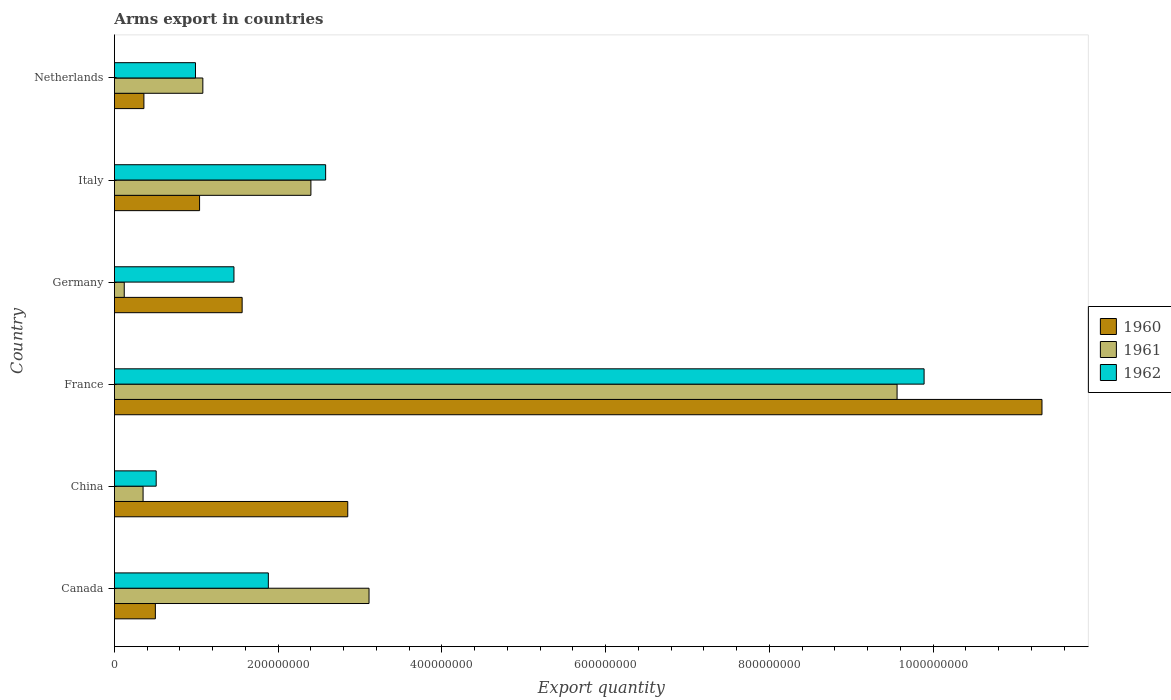How many groups of bars are there?
Offer a terse response. 6. How many bars are there on the 6th tick from the top?
Provide a short and direct response. 3. What is the label of the 2nd group of bars from the top?
Keep it short and to the point. Italy. In how many cases, is the number of bars for a given country not equal to the number of legend labels?
Offer a terse response. 0. What is the total arms export in 1960 in Netherlands?
Your answer should be compact. 3.60e+07. Across all countries, what is the maximum total arms export in 1961?
Offer a very short reply. 9.56e+08. Across all countries, what is the minimum total arms export in 1962?
Provide a succinct answer. 5.10e+07. What is the total total arms export in 1962 in the graph?
Offer a very short reply. 1.73e+09. What is the difference between the total arms export in 1960 in Canada and that in Germany?
Provide a succinct answer. -1.06e+08. What is the difference between the total arms export in 1961 in China and the total arms export in 1960 in France?
Your answer should be compact. -1.10e+09. What is the average total arms export in 1960 per country?
Offer a terse response. 2.94e+08. What is the difference between the total arms export in 1961 and total arms export in 1962 in China?
Offer a very short reply. -1.60e+07. What is the ratio of the total arms export in 1961 in China to that in Netherlands?
Keep it short and to the point. 0.32. Is the difference between the total arms export in 1961 in Italy and Netherlands greater than the difference between the total arms export in 1962 in Italy and Netherlands?
Ensure brevity in your answer.  No. What is the difference between the highest and the second highest total arms export in 1962?
Make the answer very short. 7.31e+08. What is the difference between the highest and the lowest total arms export in 1961?
Keep it short and to the point. 9.44e+08. In how many countries, is the total arms export in 1961 greater than the average total arms export in 1961 taken over all countries?
Ensure brevity in your answer.  2. What does the 2nd bar from the top in Canada represents?
Your answer should be compact. 1961. What does the 1st bar from the bottom in Italy represents?
Your response must be concise. 1960. How many bars are there?
Offer a very short reply. 18. What is the difference between two consecutive major ticks on the X-axis?
Give a very brief answer. 2.00e+08. Are the values on the major ticks of X-axis written in scientific E-notation?
Your answer should be compact. No. Does the graph contain any zero values?
Offer a terse response. No. Does the graph contain grids?
Offer a terse response. No. Where does the legend appear in the graph?
Keep it short and to the point. Center right. How many legend labels are there?
Offer a terse response. 3. What is the title of the graph?
Ensure brevity in your answer.  Arms export in countries. Does "1972" appear as one of the legend labels in the graph?
Provide a succinct answer. No. What is the label or title of the X-axis?
Your answer should be very brief. Export quantity. What is the Export quantity in 1960 in Canada?
Provide a succinct answer. 5.00e+07. What is the Export quantity in 1961 in Canada?
Make the answer very short. 3.11e+08. What is the Export quantity in 1962 in Canada?
Your response must be concise. 1.88e+08. What is the Export quantity of 1960 in China?
Give a very brief answer. 2.85e+08. What is the Export quantity of 1961 in China?
Provide a succinct answer. 3.50e+07. What is the Export quantity in 1962 in China?
Provide a short and direct response. 5.10e+07. What is the Export quantity of 1960 in France?
Give a very brief answer. 1.13e+09. What is the Export quantity in 1961 in France?
Offer a very short reply. 9.56e+08. What is the Export quantity of 1962 in France?
Keep it short and to the point. 9.89e+08. What is the Export quantity in 1960 in Germany?
Make the answer very short. 1.56e+08. What is the Export quantity of 1961 in Germany?
Your answer should be compact. 1.20e+07. What is the Export quantity in 1962 in Germany?
Make the answer very short. 1.46e+08. What is the Export quantity in 1960 in Italy?
Provide a succinct answer. 1.04e+08. What is the Export quantity in 1961 in Italy?
Ensure brevity in your answer.  2.40e+08. What is the Export quantity in 1962 in Italy?
Offer a very short reply. 2.58e+08. What is the Export quantity of 1960 in Netherlands?
Your answer should be compact. 3.60e+07. What is the Export quantity of 1961 in Netherlands?
Offer a very short reply. 1.08e+08. What is the Export quantity of 1962 in Netherlands?
Provide a short and direct response. 9.90e+07. Across all countries, what is the maximum Export quantity of 1960?
Offer a very short reply. 1.13e+09. Across all countries, what is the maximum Export quantity in 1961?
Your answer should be compact. 9.56e+08. Across all countries, what is the maximum Export quantity in 1962?
Provide a succinct answer. 9.89e+08. Across all countries, what is the minimum Export quantity of 1960?
Your answer should be compact. 3.60e+07. Across all countries, what is the minimum Export quantity in 1962?
Provide a short and direct response. 5.10e+07. What is the total Export quantity in 1960 in the graph?
Make the answer very short. 1.76e+09. What is the total Export quantity in 1961 in the graph?
Your answer should be very brief. 1.66e+09. What is the total Export quantity in 1962 in the graph?
Give a very brief answer. 1.73e+09. What is the difference between the Export quantity in 1960 in Canada and that in China?
Your answer should be compact. -2.35e+08. What is the difference between the Export quantity in 1961 in Canada and that in China?
Ensure brevity in your answer.  2.76e+08. What is the difference between the Export quantity in 1962 in Canada and that in China?
Provide a succinct answer. 1.37e+08. What is the difference between the Export quantity in 1960 in Canada and that in France?
Offer a terse response. -1.08e+09. What is the difference between the Export quantity of 1961 in Canada and that in France?
Your answer should be compact. -6.45e+08. What is the difference between the Export quantity of 1962 in Canada and that in France?
Make the answer very short. -8.01e+08. What is the difference between the Export quantity of 1960 in Canada and that in Germany?
Your response must be concise. -1.06e+08. What is the difference between the Export quantity in 1961 in Canada and that in Germany?
Offer a terse response. 2.99e+08. What is the difference between the Export quantity of 1962 in Canada and that in Germany?
Offer a very short reply. 4.20e+07. What is the difference between the Export quantity of 1960 in Canada and that in Italy?
Offer a terse response. -5.40e+07. What is the difference between the Export quantity of 1961 in Canada and that in Italy?
Your response must be concise. 7.10e+07. What is the difference between the Export quantity in 1962 in Canada and that in Italy?
Your response must be concise. -7.00e+07. What is the difference between the Export quantity in 1960 in Canada and that in Netherlands?
Offer a terse response. 1.40e+07. What is the difference between the Export quantity in 1961 in Canada and that in Netherlands?
Your answer should be compact. 2.03e+08. What is the difference between the Export quantity of 1962 in Canada and that in Netherlands?
Give a very brief answer. 8.90e+07. What is the difference between the Export quantity in 1960 in China and that in France?
Offer a very short reply. -8.48e+08. What is the difference between the Export quantity of 1961 in China and that in France?
Offer a terse response. -9.21e+08. What is the difference between the Export quantity of 1962 in China and that in France?
Provide a succinct answer. -9.38e+08. What is the difference between the Export quantity of 1960 in China and that in Germany?
Your response must be concise. 1.29e+08. What is the difference between the Export quantity in 1961 in China and that in Germany?
Your response must be concise. 2.30e+07. What is the difference between the Export quantity of 1962 in China and that in Germany?
Your answer should be compact. -9.50e+07. What is the difference between the Export quantity of 1960 in China and that in Italy?
Provide a succinct answer. 1.81e+08. What is the difference between the Export quantity of 1961 in China and that in Italy?
Offer a very short reply. -2.05e+08. What is the difference between the Export quantity of 1962 in China and that in Italy?
Make the answer very short. -2.07e+08. What is the difference between the Export quantity in 1960 in China and that in Netherlands?
Make the answer very short. 2.49e+08. What is the difference between the Export quantity in 1961 in China and that in Netherlands?
Offer a terse response. -7.30e+07. What is the difference between the Export quantity in 1962 in China and that in Netherlands?
Ensure brevity in your answer.  -4.80e+07. What is the difference between the Export quantity in 1960 in France and that in Germany?
Keep it short and to the point. 9.77e+08. What is the difference between the Export quantity of 1961 in France and that in Germany?
Provide a short and direct response. 9.44e+08. What is the difference between the Export quantity in 1962 in France and that in Germany?
Ensure brevity in your answer.  8.43e+08. What is the difference between the Export quantity of 1960 in France and that in Italy?
Make the answer very short. 1.03e+09. What is the difference between the Export quantity in 1961 in France and that in Italy?
Give a very brief answer. 7.16e+08. What is the difference between the Export quantity of 1962 in France and that in Italy?
Give a very brief answer. 7.31e+08. What is the difference between the Export quantity in 1960 in France and that in Netherlands?
Offer a terse response. 1.10e+09. What is the difference between the Export quantity of 1961 in France and that in Netherlands?
Keep it short and to the point. 8.48e+08. What is the difference between the Export quantity of 1962 in France and that in Netherlands?
Your answer should be compact. 8.90e+08. What is the difference between the Export quantity in 1960 in Germany and that in Italy?
Provide a short and direct response. 5.20e+07. What is the difference between the Export quantity of 1961 in Germany and that in Italy?
Keep it short and to the point. -2.28e+08. What is the difference between the Export quantity in 1962 in Germany and that in Italy?
Provide a short and direct response. -1.12e+08. What is the difference between the Export quantity in 1960 in Germany and that in Netherlands?
Offer a very short reply. 1.20e+08. What is the difference between the Export quantity of 1961 in Germany and that in Netherlands?
Provide a succinct answer. -9.60e+07. What is the difference between the Export quantity of 1962 in Germany and that in Netherlands?
Provide a short and direct response. 4.70e+07. What is the difference between the Export quantity of 1960 in Italy and that in Netherlands?
Offer a very short reply. 6.80e+07. What is the difference between the Export quantity in 1961 in Italy and that in Netherlands?
Offer a very short reply. 1.32e+08. What is the difference between the Export quantity of 1962 in Italy and that in Netherlands?
Keep it short and to the point. 1.59e+08. What is the difference between the Export quantity of 1960 in Canada and the Export quantity of 1961 in China?
Ensure brevity in your answer.  1.50e+07. What is the difference between the Export quantity in 1960 in Canada and the Export quantity in 1962 in China?
Your answer should be compact. -1.00e+06. What is the difference between the Export quantity of 1961 in Canada and the Export quantity of 1962 in China?
Make the answer very short. 2.60e+08. What is the difference between the Export quantity of 1960 in Canada and the Export quantity of 1961 in France?
Provide a succinct answer. -9.06e+08. What is the difference between the Export quantity in 1960 in Canada and the Export quantity in 1962 in France?
Your answer should be compact. -9.39e+08. What is the difference between the Export quantity of 1961 in Canada and the Export quantity of 1962 in France?
Make the answer very short. -6.78e+08. What is the difference between the Export quantity of 1960 in Canada and the Export quantity of 1961 in Germany?
Offer a very short reply. 3.80e+07. What is the difference between the Export quantity in 1960 in Canada and the Export quantity in 1962 in Germany?
Make the answer very short. -9.60e+07. What is the difference between the Export quantity in 1961 in Canada and the Export quantity in 1962 in Germany?
Give a very brief answer. 1.65e+08. What is the difference between the Export quantity of 1960 in Canada and the Export quantity of 1961 in Italy?
Your response must be concise. -1.90e+08. What is the difference between the Export quantity of 1960 in Canada and the Export quantity of 1962 in Italy?
Your response must be concise. -2.08e+08. What is the difference between the Export quantity in 1961 in Canada and the Export quantity in 1962 in Italy?
Provide a succinct answer. 5.30e+07. What is the difference between the Export quantity in 1960 in Canada and the Export quantity in 1961 in Netherlands?
Provide a short and direct response. -5.80e+07. What is the difference between the Export quantity in 1960 in Canada and the Export quantity in 1962 in Netherlands?
Your answer should be very brief. -4.90e+07. What is the difference between the Export quantity of 1961 in Canada and the Export quantity of 1962 in Netherlands?
Keep it short and to the point. 2.12e+08. What is the difference between the Export quantity in 1960 in China and the Export quantity in 1961 in France?
Provide a succinct answer. -6.71e+08. What is the difference between the Export quantity of 1960 in China and the Export quantity of 1962 in France?
Keep it short and to the point. -7.04e+08. What is the difference between the Export quantity in 1961 in China and the Export quantity in 1962 in France?
Offer a terse response. -9.54e+08. What is the difference between the Export quantity in 1960 in China and the Export quantity in 1961 in Germany?
Make the answer very short. 2.73e+08. What is the difference between the Export quantity in 1960 in China and the Export quantity in 1962 in Germany?
Offer a very short reply. 1.39e+08. What is the difference between the Export quantity in 1961 in China and the Export quantity in 1962 in Germany?
Ensure brevity in your answer.  -1.11e+08. What is the difference between the Export quantity of 1960 in China and the Export quantity of 1961 in Italy?
Provide a succinct answer. 4.50e+07. What is the difference between the Export quantity of 1960 in China and the Export quantity of 1962 in Italy?
Provide a succinct answer. 2.70e+07. What is the difference between the Export quantity of 1961 in China and the Export quantity of 1962 in Italy?
Offer a terse response. -2.23e+08. What is the difference between the Export quantity in 1960 in China and the Export quantity in 1961 in Netherlands?
Offer a terse response. 1.77e+08. What is the difference between the Export quantity of 1960 in China and the Export quantity of 1962 in Netherlands?
Offer a terse response. 1.86e+08. What is the difference between the Export quantity of 1961 in China and the Export quantity of 1962 in Netherlands?
Make the answer very short. -6.40e+07. What is the difference between the Export quantity in 1960 in France and the Export quantity in 1961 in Germany?
Keep it short and to the point. 1.12e+09. What is the difference between the Export quantity of 1960 in France and the Export quantity of 1962 in Germany?
Keep it short and to the point. 9.87e+08. What is the difference between the Export quantity of 1961 in France and the Export quantity of 1962 in Germany?
Your answer should be compact. 8.10e+08. What is the difference between the Export quantity in 1960 in France and the Export quantity in 1961 in Italy?
Provide a short and direct response. 8.93e+08. What is the difference between the Export quantity in 1960 in France and the Export quantity in 1962 in Italy?
Ensure brevity in your answer.  8.75e+08. What is the difference between the Export quantity in 1961 in France and the Export quantity in 1962 in Italy?
Your answer should be very brief. 6.98e+08. What is the difference between the Export quantity of 1960 in France and the Export quantity of 1961 in Netherlands?
Your answer should be compact. 1.02e+09. What is the difference between the Export quantity in 1960 in France and the Export quantity in 1962 in Netherlands?
Your answer should be very brief. 1.03e+09. What is the difference between the Export quantity of 1961 in France and the Export quantity of 1962 in Netherlands?
Give a very brief answer. 8.57e+08. What is the difference between the Export quantity in 1960 in Germany and the Export quantity in 1961 in Italy?
Make the answer very short. -8.40e+07. What is the difference between the Export quantity in 1960 in Germany and the Export quantity in 1962 in Italy?
Ensure brevity in your answer.  -1.02e+08. What is the difference between the Export quantity of 1961 in Germany and the Export quantity of 1962 in Italy?
Provide a succinct answer. -2.46e+08. What is the difference between the Export quantity of 1960 in Germany and the Export quantity of 1961 in Netherlands?
Offer a very short reply. 4.80e+07. What is the difference between the Export quantity in 1960 in Germany and the Export quantity in 1962 in Netherlands?
Offer a very short reply. 5.70e+07. What is the difference between the Export quantity of 1961 in Germany and the Export quantity of 1962 in Netherlands?
Offer a terse response. -8.70e+07. What is the difference between the Export quantity in 1960 in Italy and the Export quantity in 1961 in Netherlands?
Provide a succinct answer. -4.00e+06. What is the difference between the Export quantity of 1961 in Italy and the Export quantity of 1962 in Netherlands?
Offer a very short reply. 1.41e+08. What is the average Export quantity of 1960 per country?
Your answer should be compact. 2.94e+08. What is the average Export quantity in 1961 per country?
Offer a very short reply. 2.77e+08. What is the average Export quantity in 1962 per country?
Provide a succinct answer. 2.88e+08. What is the difference between the Export quantity of 1960 and Export quantity of 1961 in Canada?
Make the answer very short. -2.61e+08. What is the difference between the Export quantity in 1960 and Export quantity in 1962 in Canada?
Your answer should be compact. -1.38e+08. What is the difference between the Export quantity in 1961 and Export quantity in 1962 in Canada?
Offer a very short reply. 1.23e+08. What is the difference between the Export quantity of 1960 and Export quantity of 1961 in China?
Ensure brevity in your answer.  2.50e+08. What is the difference between the Export quantity in 1960 and Export quantity in 1962 in China?
Provide a short and direct response. 2.34e+08. What is the difference between the Export quantity of 1961 and Export quantity of 1962 in China?
Ensure brevity in your answer.  -1.60e+07. What is the difference between the Export quantity of 1960 and Export quantity of 1961 in France?
Provide a succinct answer. 1.77e+08. What is the difference between the Export quantity of 1960 and Export quantity of 1962 in France?
Give a very brief answer. 1.44e+08. What is the difference between the Export quantity in 1961 and Export quantity in 1962 in France?
Give a very brief answer. -3.30e+07. What is the difference between the Export quantity of 1960 and Export quantity of 1961 in Germany?
Make the answer very short. 1.44e+08. What is the difference between the Export quantity in 1960 and Export quantity in 1962 in Germany?
Offer a terse response. 1.00e+07. What is the difference between the Export quantity of 1961 and Export quantity of 1962 in Germany?
Provide a succinct answer. -1.34e+08. What is the difference between the Export quantity in 1960 and Export quantity in 1961 in Italy?
Your answer should be compact. -1.36e+08. What is the difference between the Export quantity in 1960 and Export quantity in 1962 in Italy?
Offer a very short reply. -1.54e+08. What is the difference between the Export quantity of 1961 and Export quantity of 1962 in Italy?
Your answer should be very brief. -1.80e+07. What is the difference between the Export quantity of 1960 and Export quantity of 1961 in Netherlands?
Your answer should be compact. -7.20e+07. What is the difference between the Export quantity in 1960 and Export quantity in 1962 in Netherlands?
Make the answer very short. -6.30e+07. What is the difference between the Export quantity of 1961 and Export quantity of 1962 in Netherlands?
Offer a very short reply. 9.00e+06. What is the ratio of the Export quantity of 1960 in Canada to that in China?
Ensure brevity in your answer.  0.18. What is the ratio of the Export quantity of 1961 in Canada to that in China?
Offer a very short reply. 8.89. What is the ratio of the Export quantity in 1962 in Canada to that in China?
Ensure brevity in your answer.  3.69. What is the ratio of the Export quantity of 1960 in Canada to that in France?
Give a very brief answer. 0.04. What is the ratio of the Export quantity of 1961 in Canada to that in France?
Offer a terse response. 0.33. What is the ratio of the Export quantity of 1962 in Canada to that in France?
Your answer should be compact. 0.19. What is the ratio of the Export quantity of 1960 in Canada to that in Germany?
Provide a succinct answer. 0.32. What is the ratio of the Export quantity of 1961 in Canada to that in Germany?
Make the answer very short. 25.92. What is the ratio of the Export quantity in 1962 in Canada to that in Germany?
Keep it short and to the point. 1.29. What is the ratio of the Export quantity of 1960 in Canada to that in Italy?
Give a very brief answer. 0.48. What is the ratio of the Export quantity of 1961 in Canada to that in Italy?
Make the answer very short. 1.3. What is the ratio of the Export quantity of 1962 in Canada to that in Italy?
Provide a short and direct response. 0.73. What is the ratio of the Export quantity of 1960 in Canada to that in Netherlands?
Make the answer very short. 1.39. What is the ratio of the Export quantity of 1961 in Canada to that in Netherlands?
Provide a succinct answer. 2.88. What is the ratio of the Export quantity in 1962 in Canada to that in Netherlands?
Make the answer very short. 1.9. What is the ratio of the Export quantity of 1960 in China to that in France?
Provide a short and direct response. 0.25. What is the ratio of the Export quantity of 1961 in China to that in France?
Offer a very short reply. 0.04. What is the ratio of the Export quantity of 1962 in China to that in France?
Keep it short and to the point. 0.05. What is the ratio of the Export quantity of 1960 in China to that in Germany?
Your answer should be very brief. 1.83. What is the ratio of the Export quantity in 1961 in China to that in Germany?
Keep it short and to the point. 2.92. What is the ratio of the Export quantity of 1962 in China to that in Germany?
Your response must be concise. 0.35. What is the ratio of the Export quantity in 1960 in China to that in Italy?
Offer a terse response. 2.74. What is the ratio of the Export quantity of 1961 in China to that in Italy?
Give a very brief answer. 0.15. What is the ratio of the Export quantity in 1962 in China to that in Italy?
Make the answer very short. 0.2. What is the ratio of the Export quantity of 1960 in China to that in Netherlands?
Provide a short and direct response. 7.92. What is the ratio of the Export quantity in 1961 in China to that in Netherlands?
Offer a terse response. 0.32. What is the ratio of the Export quantity in 1962 in China to that in Netherlands?
Make the answer very short. 0.52. What is the ratio of the Export quantity of 1960 in France to that in Germany?
Give a very brief answer. 7.26. What is the ratio of the Export quantity of 1961 in France to that in Germany?
Offer a very short reply. 79.67. What is the ratio of the Export quantity in 1962 in France to that in Germany?
Give a very brief answer. 6.77. What is the ratio of the Export quantity in 1960 in France to that in Italy?
Your response must be concise. 10.89. What is the ratio of the Export quantity in 1961 in France to that in Italy?
Offer a terse response. 3.98. What is the ratio of the Export quantity in 1962 in France to that in Italy?
Ensure brevity in your answer.  3.83. What is the ratio of the Export quantity of 1960 in France to that in Netherlands?
Provide a succinct answer. 31.47. What is the ratio of the Export quantity in 1961 in France to that in Netherlands?
Your answer should be compact. 8.85. What is the ratio of the Export quantity in 1962 in France to that in Netherlands?
Ensure brevity in your answer.  9.99. What is the ratio of the Export quantity of 1961 in Germany to that in Italy?
Make the answer very short. 0.05. What is the ratio of the Export quantity in 1962 in Germany to that in Italy?
Offer a terse response. 0.57. What is the ratio of the Export quantity of 1960 in Germany to that in Netherlands?
Your answer should be very brief. 4.33. What is the ratio of the Export quantity in 1961 in Germany to that in Netherlands?
Provide a short and direct response. 0.11. What is the ratio of the Export quantity in 1962 in Germany to that in Netherlands?
Make the answer very short. 1.47. What is the ratio of the Export quantity in 1960 in Italy to that in Netherlands?
Ensure brevity in your answer.  2.89. What is the ratio of the Export quantity in 1961 in Italy to that in Netherlands?
Keep it short and to the point. 2.22. What is the ratio of the Export quantity in 1962 in Italy to that in Netherlands?
Make the answer very short. 2.61. What is the difference between the highest and the second highest Export quantity in 1960?
Your answer should be compact. 8.48e+08. What is the difference between the highest and the second highest Export quantity in 1961?
Offer a very short reply. 6.45e+08. What is the difference between the highest and the second highest Export quantity of 1962?
Offer a very short reply. 7.31e+08. What is the difference between the highest and the lowest Export quantity in 1960?
Your answer should be compact. 1.10e+09. What is the difference between the highest and the lowest Export quantity of 1961?
Offer a very short reply. 9.44e+08. What is the difference between the highest and the lowest Export quantity of 1962?
Your answer should be very brief. 9.38e+08. 